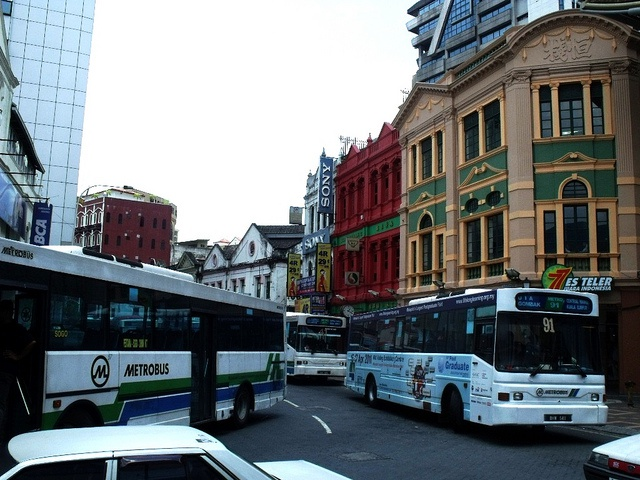Describe the objects in this image and their specific colors. I can see bus in gray and black tones, bus in gray, black, and blue tones, car in gray, lightblue, and black tones, bus in gray, black, and darkgray tones, and car in gray, black, and lightblue tones in this image. 